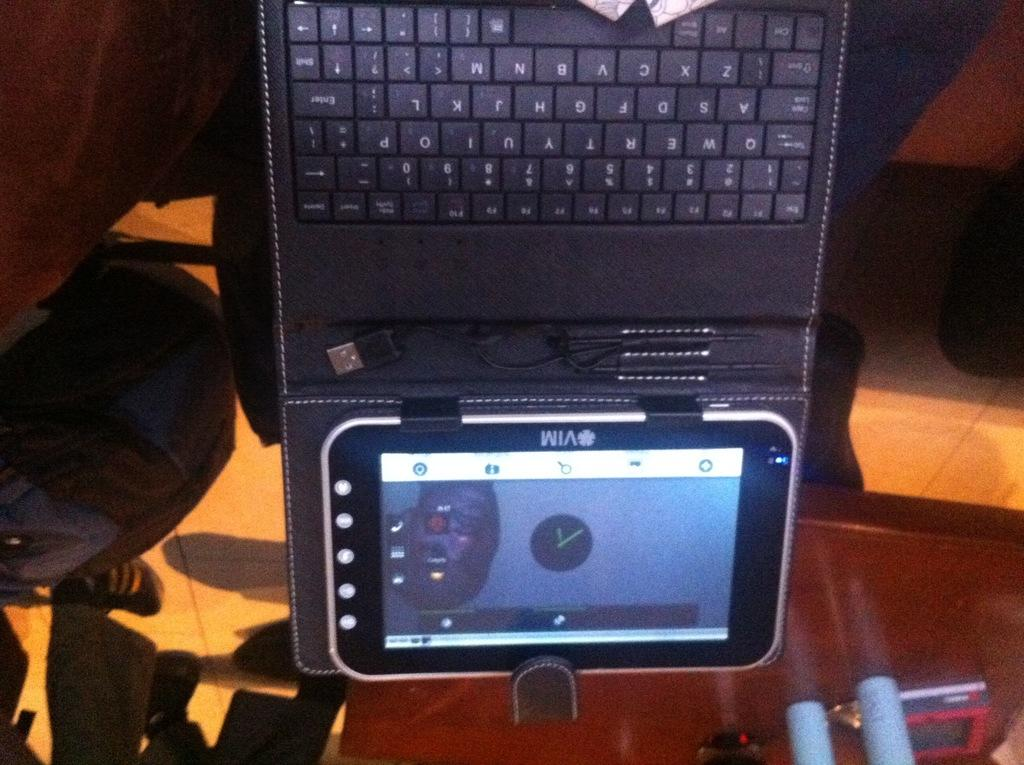<image>
Offer a succinct explanation of the picture presented. a vim branded cellphone with a clip on keyboard on top of it. 